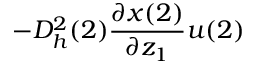Convert formula to latex. <formula><loc_0><loc_0><loc_500><loc_500>- D _ { h } ^ { 2 } ( 2 ) \frac { \partial x ( 2 ) } { \partial z _ { 1 } } u ( 2 )</formula> 